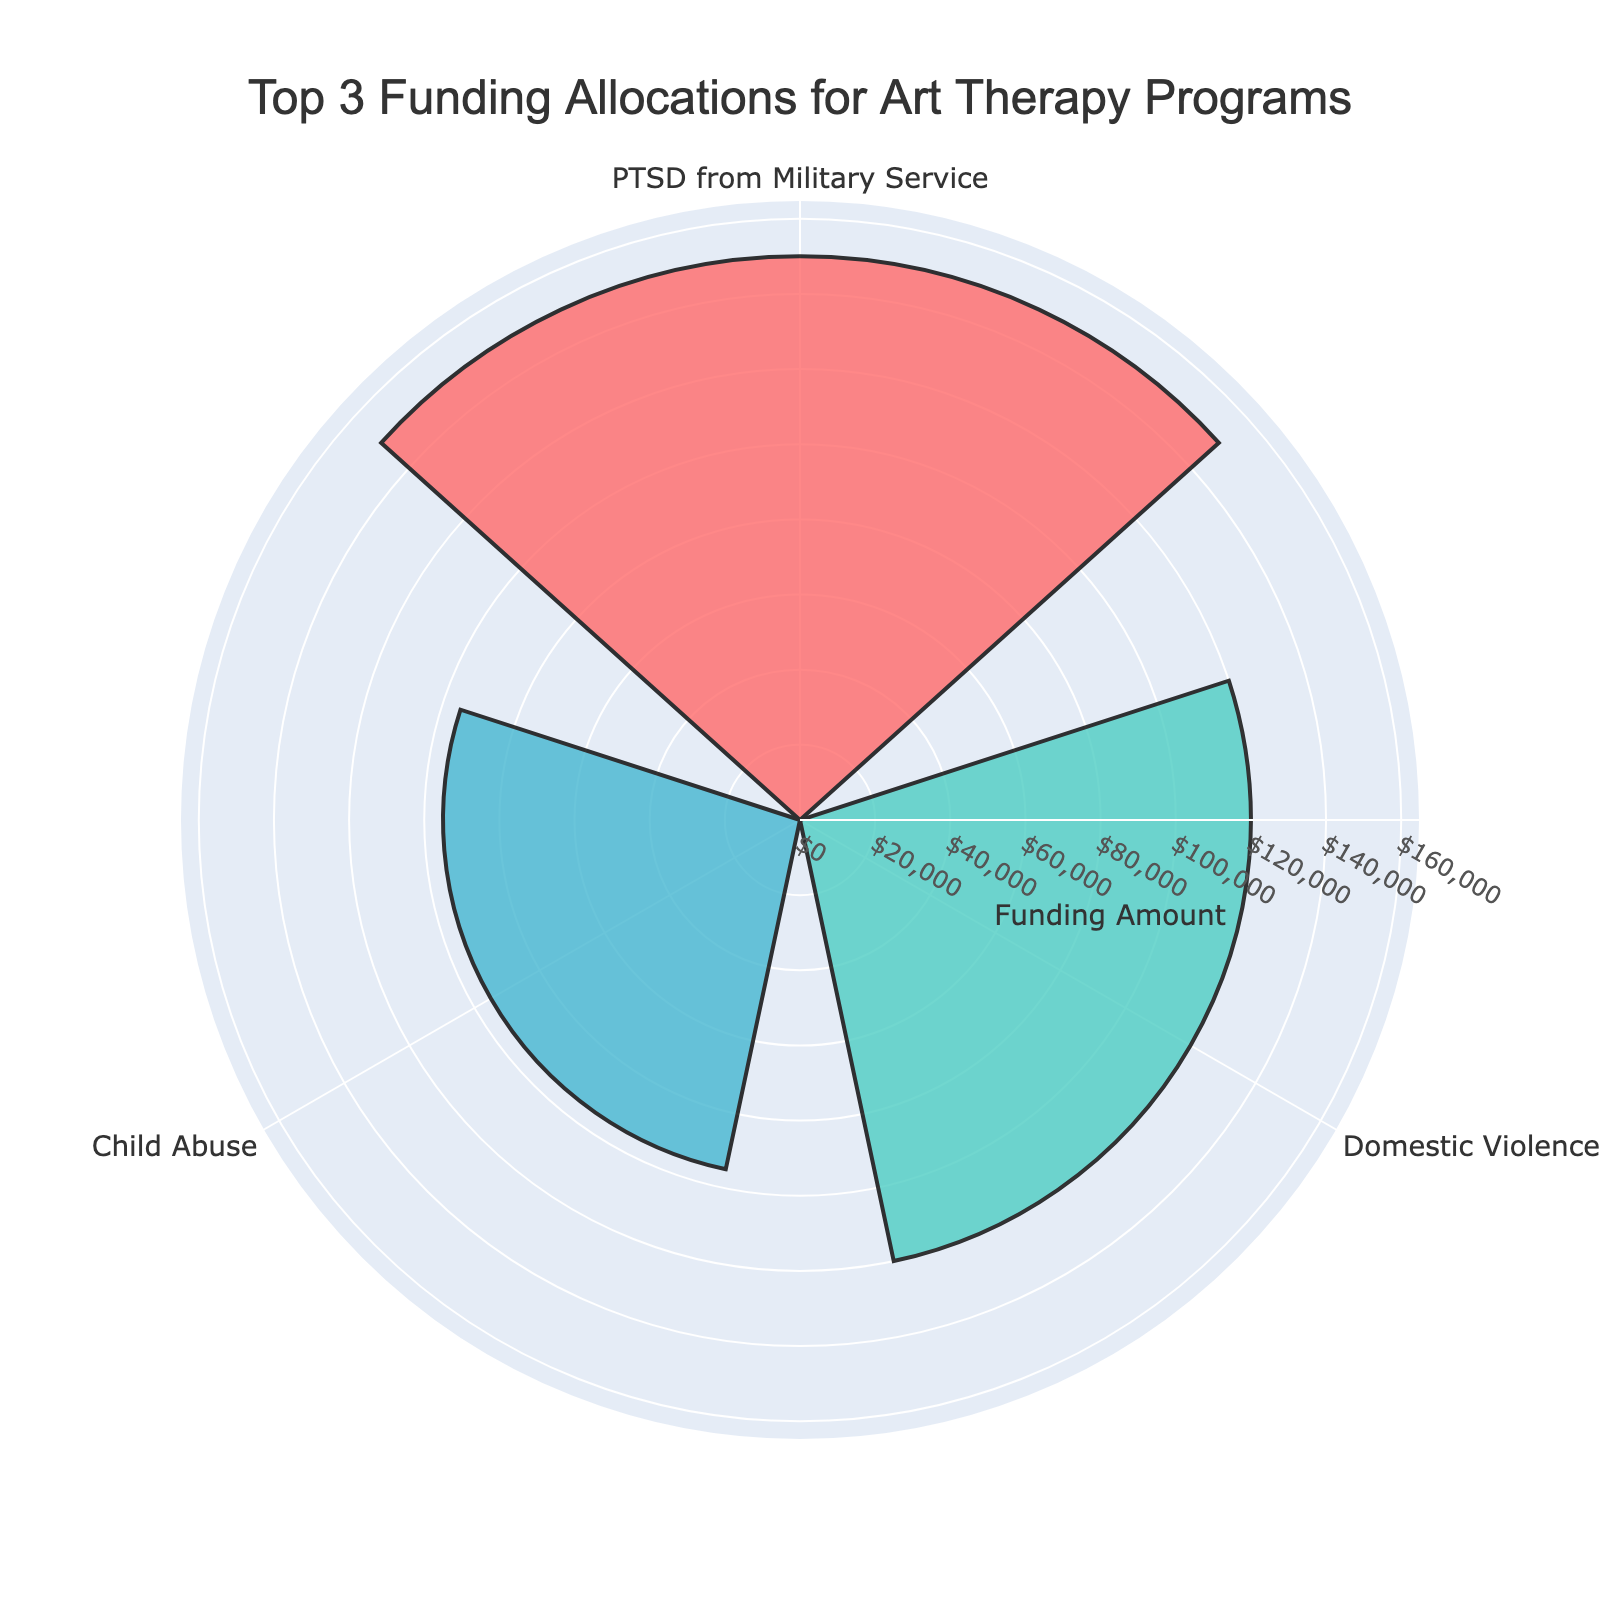1. What is the title of the rose chart? Look at the text at the top of the chart to identify the title.
Answer: Top 3 Funding Allocations for Art Therapy Programs 2. How many categories are represented in the rose chart? Count the number of labels on the chart.
Answer: 3 3. Which category received the most funding? Identify the longest bar in the chart and note its label.
Answer: PTSD from Military Service 4. By how much does the funding for PTSD from Military Service exceed funding for Child Abuse? Subtract the funding amount of Child Abuse from the funding amount of PTSD from Military Service.
Answer: $55,000 5. What are the funding amounts for each category represented in the rose chart? Read the values corresponding to each label on the chart.
Answer: PTSD from Military Service: $150,000, Domestic Violence: $120,000, Child Abuse: $95,000 6. Which category received the least funding among the top 3? Identify the shortest bar in the chart and note its label.
Answer: Child Abuse 7. How much more funding does Domestic Violence receive compared to Child Abuse? Subtract the funding amount of Child Abuse from the funding amount of Domestic Violence.
Answer: $25,000 8. What colors are used to represent each category? Identify the colors of the bars in the chart and match them with their labels.
Answer: PTSD from Military Service: Blue, Domestic Violence: Red, Child Abuse: Teal 